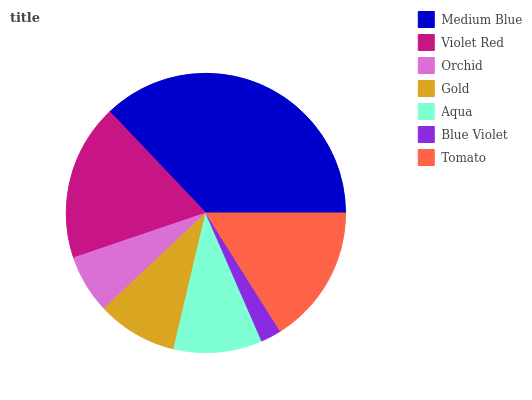Is Blue Violet the minimum?
Answer yes or no. Yes. Is Medium Blue the maximum?
Answer yes or no. Yes. Is Violet Red the minimum?
Answer yes or no. No. Is Violet Red the maximum?
Answer yes or no. No. Is Medium Blue greater than Violet Red?
Answer yes or no. Yes. Is Violet Red less than Medium Blue?
Answer yes or no. Yes. Is Violet Red greater than Medium Blue?
Answer yes or no. No. Is Medium Blue less than Violet Red?
Answer yes or no. No. Is Aqua the high median?
Answer yes or no. Yes. Is Aqua the low median?
Answer yes or no. Yes. Is Violet Red the high median?
Answer yes or no. No. Is Orchid the low median?
Answer yes or no. No. 